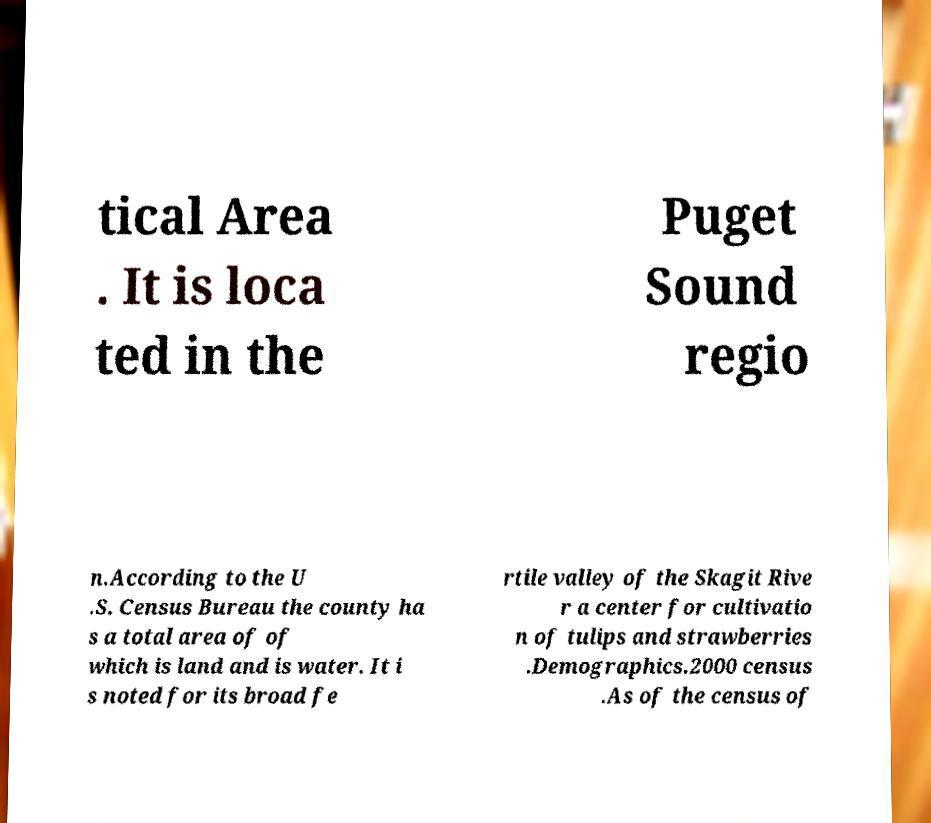Please read and relay the text visible in this image. What does it say? tical Area . It is loca ted in the Puget Sound regio n.According to the U .S. Census Bureau the county ha s a total area of of which is land and is water. It i s noted for its broad fe rtile valley of the Skagit Rive r a center for cultivatio n of tulips and strawberries .Demographics.2000 census .As of the census of 